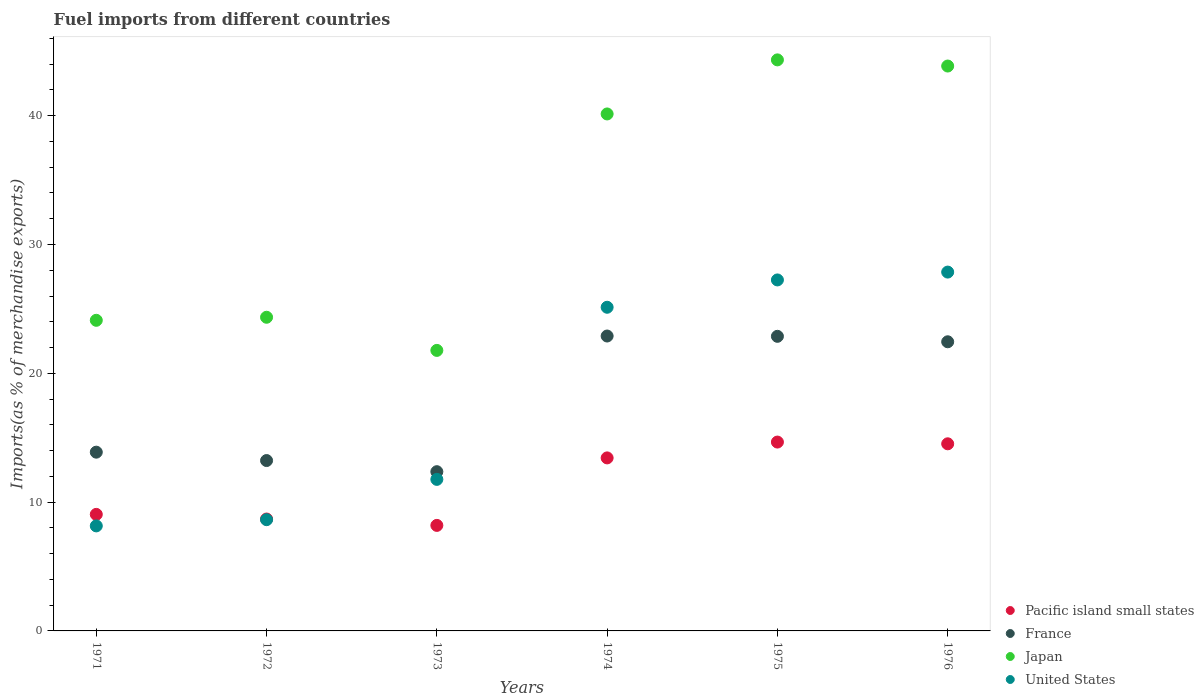How many different coloured dotlines are there?
Make the answer very short. 4. Is the number of dotlines equal to the number of legend labels?
Your answer should be very brief. Yes. What is the percentage of imports to different countries in Pacific island small states in 1972?
Your answer should be very brief. 8.69. Across all years, what is the maximum percentage of imports to different countries in Pacific island small states?
Make the answer very short. 14.66. Across all years, what is the minimum percentage of imports to different countries in United States?
Your answer should be compact. 8.15. In which year was the percentage of imports to different countries in Pacific island small states maximum?
Your answer should be very brief. 1975. In which year was the percentage of imports to different countries in Pacific island small states minimum?
Provide a short and direct response. 1973. What is the total percentage of imports to different countries in Japan in the graph?
Ensure brevity in your answer.  198.56. What is the difference between the percentage of imports to different countries in Japan in 1972 and that in 1974?
Offer a very short reply. -15.78. What is the difference between the percentage of imports to different countries in United States in 1971 and the percentage of imports to different countries in France in 1974?
Your answer should be compact. -14.74. What is the average percentage of imports to different countries in Pacific island small states per year?
Provide a short and direct response. 11.42. In the year 1971, what is the difference between the percentage of imports to different countries in Pacific island small states and percentage of imports to different countries in United States?
Give a very brief answer. 0.89. In how many years, is the percentage of imports to different countries in Japan greater than 2 %?
Give a very brief answer. 6. What is the ratio of the percentage of imports to different countries in Pacific island small states in 1971 to that in 1974?
Your answer should be very brief. 0.67. Is the percentage of imports to different countries in France in 1972 less than that in 1973?
Offer a very short reply. No. What is the difference between the highest and the second highest percentage of imports to different countries in France?
Offer a very short reply. 0.02. What is the difference between the highest and the lowest percentage of imports to different countries in Pacific island small states?
Keep it short and to the point. 6.47. In how many years, is the percentage of imports to different countries in United States greater than the average percentage of imports to different countries in United States taken over all years?
Provide a short and direct response. 3. Is the sum of the percentage of imports to different countries in United States in 1971 and 1974 greater than the maximum percentage of imports to different countries in France across all years?
Your answer should be compact. Yes. Is the percentage of imports to different countries in France strictly greater than the percentage of imports to different countries in Japan over the years?
Provide a succinct answer. No. Is the percentage of imports to different countries in France strictly less than the percentage of imports to different countries in United States over the years?
Your answer should be compact. No. How many dotlines are there?
Your response must be concise. 4. Are the values on the major ticks of Y-axis written in scientific E-notation?
Your answer should be compact. No. How many legend labels are there?
Offer a very short reply. 4. How are the legend labels stacked?
Offer a terse response. Vertical. What is the title of the graph?
Offer a terse response. Fuel imports from different countries. What is the label or title of the Y-axis?
Give a very brief answer. Imports(as % of merchandise exports). What is the Imports(as % of merchandise exports) in Pacific island small states in 1971?
Keep it short and to the point. 9.05. What is the Imports(as % of merchandise exports) in France in 1971?
Your response must be concise. 13.88. What is the Imports(as % of merchandise exports) in Japan in 1971?
Offer a very short reply. 24.11. What is the Imports(as % of merchandise exports) in United States in 1971?
Your answer should be very brief. 8.15. What is the Imports(as % of merchandise exports) of Pacific island small states in 1972?
Give a very brief answer. 8.69. What is the Imports(as % of merchandise exports) of France in 1972?
Provide a short and direct response. 13.23. What is the Imports(as % of merchandise exports) in Japan in 1972?
Offer a very short reply. 24.35. What is the Imports(as % of merchandise exports) in United States in 1972?
Your answer should be compact. 8.64. What is the Imports(as % of merchandise exports) in Pacific island small states in 1973?
Ensure brevity in your answer.  8.19. What is the Imports(as % of merchandise exports) in France in 1973?
Provide a short and direct response. 12.36. What is the Imports(as % of merchandise exports) in Japan in 1973?
Provide a succinct answer. 21.78. What is the Imports(as % of merchandise exports) in United States in 1973?
Your answer should be compact. 11.76. What is the Imports(as % of merchandise exports) of Pacific island small states in 1974?
Ensure brevity in your answer.  13.43. What is the Imports(as % of merchandise exports) in France in 1974?
Give a very brief answer. 22.89. What is the Imports(as % of merchandise exports) of Japan in 1974?
Your response must be concise. 40.13. What is the Imports(as % of merchandise exports) in United States in 1974?
Your answer should be compact. 25.13. What is the Imports(as % of merchandise exports) in Pacific island small states in 1975?
Provide a short and direct response. 14.66. What is the Imports(as % of merchandise exports) in France in 1975?
Give a very brief answer. 22.87. What is the Imports(as % of merchandise exports) in Japan in 1975?
Keep it short and to the point. 44.33. What is the Imports(as % of merchandise exports) of United States in 1975?
Provide a short and direct response. 27.25. What is the Imports(as % of merchandise exports) of Pacific island small states in 1976?
Offer a terse response. 14.53. What is the Imports(as % of merchandise exports) in France in 1976?
Your response must be concise. 22.45. What is the Imports(as % of merchandise exports) in Japan in 1976?
Keep it short and to the point. 43.85. What is the Imports(as % of merchandise exports) in United States in 1976?
Your response must be concise. 27.86. Across all years, what is the maximum Imports(as % of merchandise exports) of Pacific island small states?
Offer a very short reply. 14.66. Across all years, what is the maximum Imports(as % of merchandise exports) in France?
Offer a terse response. 22.89. Across all years, what is the maximum Imports(as % of merchandise exports) of Japan?
Make the answer very short. 44.33. Across all years, what is the maximum Imports(as % of merchandise exports) of United States?
Provide a short and direct response. 27.86. Across all years, what is the minimum Imports(as % of merchandise exports) of Pacific island small states?
Ensure brevity in your answer.  8.19. Across all years, what is the minimum Imports(as % of merchandise exports) of France?
Your response must be concise. 12.36. Across all years, what is the minimum Imports(as % of merchandise exports) of Japan?
Offer a terse response. 21.78. Across all years, what is the minimum Imports(as % of merchandise exports) in United States?
Your response must be concise. 8.15. What is the total Imports(as % of merchandise exports) of Pacific island small states in the graph?
Keep it short and to the point. 68.55. What is the total Imports(as % of merchandise exports) of France in the graph?
Offer a very short reply. 107.68. What is the total Imports(as % of merchandise exports) in Japan in the graph?
Ensure brevity in your answer.  198.56. What is the total Imports(as % of merchandise exports) in United States in the graph?
Make the answer very short. 108.79. What is the difference between the Imports(as % of merchandise exports) in Pacific island small states in 1971 and that in 1972?
Provide a short and direct response. 0.36. What is the difference between the Imports(as % of merchandise exports) in France in 1971 and that in 1972?
Your answer should be compact. 0.65. What is the difference between the Imports(as % of merchandise exports) in Japan in 1971 and that in 1972?
Offer a terse response. -0.24. What is the difference between the Imports(as % of merchandise exports) of United States in 1971 and that in 1972?
Make the answer very short. -0.48. What is the difference between the Imports(as % of merchandise exports) of Pacific island small states in 1971 and that in 1973?
Ensure brevity in your answer.  0.86. What is the difference between the Imports(as % of merchandise exports) of France in 1971 and that in 1973?
Your answer should be very brief. 1.51. What is the difference between the Imports(as % of merchandise exports) in Japan in 1971 and that in 1973?
Make the answer very short. 2.34. What is the difference between the Imports(as % of merchandise exports) of United States in 1971 and that in 1973?
Keep it short and to the point. -3.61. What is the difference between the Imports(as % of merchandise exports) of Pacific island small states in 1971 and that in 1974?
Offer a very short reply. -4.38. What is the difference between the Imports(as % of merchandise exports) of France in 1971 and that in 1974?
Your response must be concise. -9.02. What is the difference between the Imports(as % of merchandise exports) of Japan in 1971 and that in 1974?
Keep it short and to the point. -16.02. What is the difference between the Imports(as % of merchandise exports) in United States in 1971 and that in 1974?
Provide a succinct answer. -16.97. What is the difference between the Imports(as % of merchandise exports) of Pacific island small states in 1971 and that in 1975?
Provide a succinct answer. -5.61. What is the difference between the Imports(as % of merchandise exports) of France in 1971 and that in 1975?
Your answer should be compact. -8.99. What is the difference between the Imports(as % of merchandise exports) in Japan in 1971 and that in 1975?
Provide a succinct answer. -20.22. What is the difference between the Imports(as % of merchandise exports) of United States in 1971 and that in 1975?
Your response must be concise. -19.09. What is the difference between the Imports(as % of merchandise exports) in Pacific island small states in 1971 and that in 1976?
Keep it short and to the point. -5.48. What is the difference between the Imports(as % of merchandise exports) of France in 1971 and that in 1976?
Your answer should be compact. -8.57. What is the difference between the Imports(as % of merchandise exports) of Japan in 1971 and that in 1976?
Provide a succinct answer. -19.74. What is the difference between the Imports(as % of merchandise exports) in United States in 1971 and that in 1976?
Offer a terse response. -19.7. What is the difference between the Imports(as % of merchandise exports) of Pacific island small states in 1972 and that in 1973?
Keep it short and to the point. 0.49. What is the difference between the Imports(as % of merchandise exports) of France in 1972 and that in 1973?
Keep it short and to the point. 0.86. What is the difference between the Imports(as % of merchandise exports) in Japan in 1972 and that in 1973?
Provide a short and direct response. 2.57. What is the difference between the Imports(as % of merchandise exports) in United States in 1972 and that in 1973?
Offer a very short reply. -3.13. What is the difference between the Imports(as % of merchandise exports) of Pacific island small states in 1972 and that in 1974?
Offer a very short reply. -4.74. What is the difference between the Imports(as % of merchandise exports) of France in 1972 and that in 1974?
Give a very brief answer. -9.67. What is the difference between the Imports(as % of merchandise exports) in Japan in 1972 and that in 1974?
Keep it short and to the point. -15.78. What is the difference between the Imports(as % of merchandise exports) in United States in 1972 and that in 1974?
Offer a terse response. -16.49. What is the difference between the Imports(as % of merchandise exports) of Pacific island small states in 1972 and that in 1975?
Your answer should be compact. -5.97. What is the difference between the Imports(as % of merchandise exports) in France in 1972 and that in 1975?
Make the answer very short. -9.64. What is the difference between the Imports(as % of merchandise exports) in Japan in 1972 and that in 1975?
Give a very brief answer. -19.98. What is the difference between the Imports(as % of merchandise exports) in United States in 1972 and that in 1975?
Offer a very short reply. -18.61. What is the difference between the Imports(as % of merchandise exports) of Pacific island small states in 1972 and that in 1976?
Your answer should be compact. -5.84. What is the difference between the Imports(as % of merchandise exports) in France in 1972 and that in 1976?
Your answer should be compact. -9.22. What is the difference between the Imports(as % of merchandise exports) in Japan in 1972 and that in 1976?
Provide a short and direct response. -19.5. What is the difference between the Imports(as % of merchandise exports) in United States in 1972 and that in 1976?
Provide a short and direct response. -19.22. What is the difference between the Imports(as % of merchandise exports) in Pacific island small states in 1973 and that in 1974?
Offer a very short reply. -5.24. What is the difference between the Imports(as % of merchandise exports) in France in 1973 and that in 1974?
Give a very brief answer. -10.53. What is the difference between the Imports(as % of merchandise exports) of Japan in 1973 and that in 1974?
Your answer should be compact. -18.36. What is the difference between the Imports(as % of merchandise exports) of United States in 1973 and that in 1974?
Your response must be concise. -13.36. What is the difference between the Imports(as % of merchandise exports) of Pacific island small states in 1973 and that in 1975?
Provide a succinct answer. -6.47. What is the difference between the Imports(as % of merchandise exports) in France in 1973 and that in 1975?
Provide a succinct answer. -10.51. What is the difference between the Imports(as % of merchandise exports) of Japan in 1973 and that in 1975?
Offer a very short reply. -22.55. What is the difference between the Imports(as % of merchandise exports) in United States in 1973 and that in 1975?
Provide a succinct answer. -15.48. What is the difference between the Imports(as % of merchandise exports) in Pacific island small states in 1973 and that in 1976?
Keep it short and to the point. -6.33. What is the difference between the Imports(as % of merchandise exports) of France in 1973 and that in 1976?
Your response must be concise. -10.08. What is the difference between the Imports(as % of merchandise exports) in Japan in 1973 and that in 1976?
Offer a very short reply. -22.08. What is the difference between the Imports(as % of merchandise exports) in United States in 1973 and that in 1976?
Ensure brevity in your answer.  -16.09. What is the difference between the Imports(as % of merchandise exports) of Pacific island small states in 1974 and that in 1975?
Offer a terse response. -1.23. What is the difference between the Imports(as % of merchandise exports) of France in 1974 and that in 1975?
Your answer should be very brief. 0.02. What is the difference between the Imports(as % of merchandise exports) in Japan in 1974 and that in 1975?
Your response must be concise. -4.2. What is the difference between the Imports(as % of merchandise exports) of United States in 1974 and that in 1975?
Provide a short and direct response. -2.12. What is the difference between the Imports(as % of merchandise exports) in Pacific island small states in 1974 and that in 1976?
Your response must be concise. -1.09. What is the difference between the Imports(as % of merchandise exports) of France in 1974 and that in 1976?
Offer a terse response. 0.45. What is the difference between the Imports(as % of merchandise exports) in Japan in 1974 and that in 1976?
Your answer should be compact. -3.72. What is the difference between the Imports(as % of merchandise exports) in United States in 1974 and that in 1976?
Offer a very short reply. -2.73. What is the difference between the Imports(as % of merchandise exports) in Pacific island small states in 1975 and that in 1976?
Your response must be concise. 0.13. What is the difference between the Imports(as % of merchandise exports) of France in 1975 and that in 1976?
Your response must be concise. 0.42. What is the difference between the Imports(as % of merchandise exports) of Japan in 1975 and that in 1976?
Make the answer very short. 0.48. What is the difference between the Imports(as % of merchandise exports) of United States in 1975 and that in 1976?
Offer a very short reply. -0.61. What is the difference between the Imports(as % of merchandise exports) of Pacific island small states in 1971 and the Imports(as % of merchandise exports) of France in 1972?
Make the answer very short. -4.18. What is the difference between the Imports(as % of merchandise exports) in Pacific island small states in 1971 and the Imports(as % of merchandise exports) in Japan in 1972?
Your response must be concise. -15.3. What is the difference between the Imports(as % of merchandise exports) in Pacific island small states in 1971 and the Imports(as % of merchandise exports) in United States in 1972?
Give a very brief answer. 0.41. What is the difference between the Imports(as % of merchandise exports) in France in 1971 and the Imports(as % of merchandise exports) in Japan in 1972?
Your answer should be compact. -10.47. What is the difference between the Imports(as % of merchandise exports) of France in 1971 and the Imports(as % of merchandise exports) of United States in 1972?
Provide a succinct answer. 5.24. What is the difference between the Imports(as % of merchandise exports) of Japan in 1971 and the Imports(as % of merchandise exports) of United States in 1972?
Your response must be concise. 15.48. What is the difference between the Imports(as % of merchandise exports) of Pacific island small states in 1971 and the Imports(as % of merchandise exports) of France in 1973?
Offer a very short reply. -3.31. What is the difference between the Imports(as % of merchandise exports) of Pacific island small states in 1971 and the Imports(as % of merchandise exports) of Japan in 1973?
Your answer should be compact. -12.73. What is the difference between the Imports(as % of merchandise exports) of Pacific island small states in 1971 and the Imports(as % of merchandise exports) of United States in 1973?
Keep it short and to the point. -2.72. What is the difference between the Imports(as % of merchandise exports) of France in 1971 and the Imports(as % of merchandise exports) of Japan in 1973?
Make the answer very short. -7.9. What is the difference between the Imports(as % of merchandise exports) in France in 1971 and the Imports(as % of merchandise exports) in United States in 1973?
Your answer should be very brief. 2.11. What is the difference between the Imports(as % of merchandise exports) of Japan in 1971 and the Imports(as % of merchandise exports) of United States in 1973?
Provide a succinct answer. 12.35. What is the difference between the Imports(as % of merchandise exports) in Pacific island small states in 1971 and the Imports(as % of merchandise exports) in France in 1974?
Make the answer very short. -13.85. What is the difference between the Imports(as % of merchandise exports) in Pacific island small states in 1971 and the Imports(as % of merchandise exports) in Japan in 1974?
Ensure brevity in your answer.  -31.09. What is the difference between the Imports(as % of merchandise exports) in Pacific island small states in 1971 and the Imports(as % of merchandise exports) in United States in 1974?
Provide a short and direct response. -16.08. What is the difference between the Imports(as % of merchandise exports) in France in 1971 and the Imports(as % of merchandise exports) in Japan in 1974?
Ensure brevity in your answer.  -26.26. What is the difference between the Imports(as % of merchandise exports) in France in 1971 and the Imports(as % of merchandise exports) in United States in 1974?
Make the answer very short. -11.25. What is the difference between the Imports(as % of merchandise exports) of Japan in 1971 and the Imports(as % of merchandise exports) of United States in 1974?
Your response must be concise. -1.01. What is the difference between the Imports(as % of merchandise exports) of Pacific island small states in 1971 and the Imports(as % of merchandise exports) of France in 1975?
Keep it short and to the point. -13.82. What is the difference between the Imports(as % of merchandise exports) of Pacific island small states in 1971 and the Imports(as % of merchandise exports) of Japan in 1975?
Offer a very short reply. -35.28. What is the difference between the Imports(as % of merchandise exports) of Pacific island small states in 1971 and the Imports(as % of merchandise exports) of United States in 1975?
Your answer should be compact. -18.2. What is the difference between the Imports(as % of merchandise exports) in France in 1971 and the Imports(as % of merchandise exports) in Japan in 1975?
Keep it short and to the point. -30.45. What is the difference between the Imports(as % of merchandise exports) of France in 1971 and the Imports(as % of merchandise exports) of United States in 1975?
Provide a succinct answer. -13.37. What is the difference between the Imports(as % of merchandise exports) of Japan in 1971 and the Imports(as % of merchandise exports) of United States in 1975?
Offer a very short reply. -3.13. What is the difference between the Imports(as % of merchandise exports) in Pacific island small states in 1971 and the Imports(as % of merchandise exports) in France in 1976?
Keep it short and to the point. -13.4. What is the difference between the Imports(as % of merchandise exports) in Pacific island small states in 1971 and the Imports(as % of merchandise exports) in Japan in 1976?
Provide a short and direct response. -34.81. What is the difference between the Imports(as % of merchandise exports) in Pacific island small states in 1971 and the Imports(as % of merchandise exports) in United States in 1976?
Your answer should be compact. -18.81. What is the difference between the Imports(as % of merchandise exports) of France in 1971 and the Imports(as % of merchandise exports) of Japan in 1976?
Provide a succinct answer. -29.98. What is the difference between the Imports(as % of merchandise exports) in France in 1971 and the Imports(as % of merchandise exports) in United States in 1976?
Your answer should be very brief. -13.98. What is the difference between the Imports(as % of merchandise exports) in Japan in 1971 and the Imports(as % of merchandise exports) in United States in 1976?
Your answer should be compact. -3.74. What is the difference between the Imports(as % of merchandise exports) of Pacific island small states in 1972 and the Imports(as % of merchandise exports) of France in 1973?
Offer a very short reply. -3.67. What is the difference between the Imports(as % of merchandise exports) in Pacific island small states in 1972 and the Imports(as % of merchandise exports) in Japan in 1973?
Offer a very short reply. -13.09. What is the difference between the Imports(as % of merchandise exports) of Pacific island small states in 1972 and the Imports(as % of merchandise exports) of United States in 1973?
Your answer should be very brief. -3.08. What is the difference between the Imports(as % of merchandise exports) of France in 1972 and the Imports(as % of merchandise exports) of Japan in 1973?
Make the answer very short. -8.55. What is the difference between the Imports(as % of merchandise exports) in France in 1972 and the Imports(as % of merchandise exports) in United States in 1973?
Your answer should be compact. 1.46. What is the difference between the Imports(as % of merchandise exports) of Japan in 1972 and the Imports(as % of merchandise exports) of United States in 1973?
Make the answer very short. 12.59. What is the difference between the Imports(as % of merchandise exports) of Pacific island small states in 1972 and the Imports(as % of merchandise exports) of France in 1974?
Your response must be concise. -14.21. What is the difference between the Imports(as % of merchandise exports) in Pacific island small states in 1972 and the Imports(as % of merchandise exports) in Japan in 1974?
Offer a very short reply. -31.45. What is the difference between the Imports(as % of merchandise exports) in Pacific island small states in 1972 and the Imports(as % of merchandise exports) in United States in 1974?
Your answer should be compact. -16.44. What is the difference between the Imports(as % of merchandise exports) in France in 1972 and the Imports(as % of merchandise exports) in Japan in 1974?
Provide a succinct answer. -26.91. What is the difference between the Imports(as % of merchandise exports) of France in 1972 and the Imports(as % of merchandise exports) of United States in 1974?
Keep it short and to the point. -11.9. What is the difference between the Imports(as % of merchandise exports) of Japan in 1972 and the Imports(as % of merchandise exports) of United States in 1974?
Offer a very short reply. -0.78. What is the difference between the Imports(as % of merchandise exports) of Pacific island small states in 1972 and the Imports(as % of merchandise exports) of France in 1975?
Provide a succinct answer. -14.18. What is the difference between the Imports(as % of merchandise exports) in Pacific island small states in 1972 and the Imports(as % of merchandise exports) in Japan in 1975?
Provide a succinct answer. -35.64. What is the difference between the Imports(as % of merchandise exports) in Pacific island small states in 1972 and the Imports(as % of merchandise exports) in United States in 1975?
Give a very brief answer. -18.56. What is the difference between the Imports(as % of merchandise exports) of France in 1972 and the Imports(as % of merchandise exports) of Japan in 1975?
Your answer should be compact. -31.1. What is the difference between the Imports(as % of merchandise exports) of France in 1972 and the Imports(as % of merchandise exports) of United States in 1975?
Make the answer very short. -14.02. What is the difference between the Imports(as % of merchandise exports) in Japan in 1972 and the Imports(as % of merchandise exports) in United States in 1975?
Give a very brief answer. -2.9. What is the difference between the Imports(as % of merchandise exports) in Pacific island small states in 1972 and the Imports(as % of merchandise exports) in France in 1976?
Keep it short and to the point. -13.76. What is the difference between the Imports(as % of merchandise exports) in Pacific island small states in 1972 and the Imports(as % of merchandise exports) in Japan in 1976?
Give a very brief answer. -35.17. What is the difference between the Imports(as % of merchandise exports) in Pacific island small states in 1972 and the Imports(as % of merchandise exports) in United States in 1976?
Offer a very short reply. -19.17. What is the difference between the Imports(as % of merchandise exports) in France in 1972 and the Imports(as % of merchandise exports) in Japan in 1976?
Provide a short and direct response. -30.63. What is the difference between the Imports(as % of merchandise exports) in France in 1972 and the Imports(as % of merchandise exports) in United States in 1976?
Keep it short and to the point. -14.63. What is the difference between the Imports(as % of merchandise exports) in Japan in 1972 and the Imports(as % of merchandise exports) in United States in 1976?
Offer a terse response. -3.51. What is the difference between the Imports(as % of merchandise exports) in Pacific island small states in 1973 and the Imports(as % of merchandise exports) in France in 1974?
Provide a succinct answer. -14.7. What is the difference between the Imports(as % of merchandise exports) of Pacific island small states in 1973 and the Imports(as % of merchandise exports) of Japan in 1974?
Your answer should be very brief. -31.94. What is the difference between the Imports(as % of merchandise exports) of Pacific island small states in 1973 and the Imports(as % of merchandise exports) of United States in 1974?
Keep it short and to the point. -16.93. What is the difference between the Imports(as % of merchandise exports) of France in 1973 and the Imports(as % of merchandise exports) of Japan in 1974?
Ensure brevity in your answer.  -27.77. What is the difference between the Imports(as % of merchandise exports) in France in 1973 and the Imports(as % of merchandise exports) in United States in 1974?
Offer a very short reply. -12.76. What is the difference between the Imports(as % of merchandise exports) in Japan in 1973 and the Imports(as % of merchandise exports) in United States in 1974?
Provide a succinct answer. -3.35. What is the difference between the Imports(as % of merchandise exports) of Pacific island small states in 1973 and the Imports(as % of merchandise exports) of France in 1975?
Make the answer very short. -14.68. What is the difference between the Imports(as % of merchandise exports) of Pacific island small states in 1973 and the Imports(as % of merchandise exports) of Japan in 1975?
Your response must be concise. -36.14. What is the difference between the Imports(as % of merchandise exports) of Pacific island small states in 1973 and the Imports(as % of merchandise exports) of United States in 1975?
Provide a short and direct response. -19.06. What is the difference between the Imports(as % of merchandise exports) of France in 1973 and the Imports(as % of merchandise exports) of Japan in 1975?
Your answer should be very brief. -31.97. What is the difference between the Imports(as % of merchandise exports) in France in 1973 and the Imports(as % of merchandise exports) in United States in 1975?
Offer a terse response. -14.89. What is the difference between the Imports(as % of merchandise exports) of Japan in 1973 and the Imports(as % of merchandise exports) of United States in 1975?
Keep it short and to the point. -5.47. What is the difference between the Imports(as % of merchandise exports) of Pacific island small states in 1973 and the Imports(as % of merchandise exports) of France in 1976?
Your answer should be compact. -14.25. What is the difference between the Imports(as % of merchandise exports) of Pacific island small states in 1973 and the Imports(as % of merchandise exports) of Japan in 1976?
Provide a succinct answer. -35.66. What is the difference between the Imports(as % of merchandise exports) of Pacific island small states in 1973 and the Imports(as % of merchandise exports) of United States in 1976?
Make the answer very short. -19.66. What is the difference between the Imports(as % of merchandise exports) of France in 1973 and the Imports(as % of merchandise exports) of Japan in 1976?
Ensure brevity in your answer.  -31.49. What is the difference between the Imports(as % of merchandise exports) of France in 1973 and the Imports(as % of merchandise exports) of United States in 1976?
Your answer should be very brief. -15.5. What is the difference between the Imports(as % of merchandise exports) in Japan in 1973 and the Imports(as % of merchandise exports) in United States in 1976?
Offer a terse response. -6.08. What is the difference between the Imports(as % of merchandise exports) of Pacific island small states in 1974 and the Imports(as % of merchandise exports) of France in 1975?
Your answer should be compact. -9.44. What is the difference between the Imports(as % of merchandise exports) in Pacific island small states in 1974 and the Imports(as % of merchandise exports) in Japan in 1975?
Offer a very short reply. -30.9. What is the difference between the Imports(as % of merchandise exports) in Pacific island small states in 1974 and the Imports(as % of merchandise exports) in United States in 1975?
Ensure brevity in your answer.  -13.82. What is the difference between the Imports(as % of merchandise exports) of France in 1974 and the Imports(as % of merchandise exports) of Japan in 1975?
Your answer should be compact. -21.44. What is the difference between the Imports(as % of merchandise exports) of France in 1974 and the Imports(as % of merchandise exports) of United States in 1975?
Ensure brevity in your answer.  -4.35. What is the difference between the Imports(as % of merchandise exports) of Japan in 1974 and the Imports(as % of merchandise exports) of United States in 1975?
Your answer should be very brief. 12.89. What is the difference between the Imports(as % of merchandise exports) of Pacific island small states in 1974 and the Imports(as % of merchandise exports) of France in 1976?
Give a very brief answer. -9.01. What is the difference between the Imports(as % of merchandise exports) in Pacific island small states in 1974 and the Imports(as % of merchandise exports) in Japan in 1976?
Provide a short and direct response. -30.42. What is the difference between the Imports(as % of merchandise exports) in Pacific island small states in 1974 and the Imports(as % of merchandise exports) in United States in 1976?
Offer a terse response. -14.43. What is the difference between the Imports(as % of merchandise exports) in France in 1974 and the Imports(as % of merchandise exports) in Japan in 1976?
Your answer should be very brief. -20.96. What is the difference between the Imports(as % of merchandise exports) in France in 1974 and the Imports(as % of merchandise exports) in United States in 1976?
Your answer should be compact. -4.96. What is the difference between the Imports(as % of merchandise exports) of Japan in 1974 and the Imports(as % of merchandise exports) of United States in 1976?
Your answer should be compact. 12.28. What is the difference between the Imports(as % of merchandise exports) in Pacific island small states in 1975 and the Imports(as % of merchandise exports) in France in 1976?
Offer a very short reply. -7.79. What is the difference between the Imports(as % of merchandise exports) of Pacific island small states in 1975 and the Imports(as % of merchandise exports) of Japan in 1976?
Keep it short and to the point. -29.19. What is the difference between the Imports(as % of merchandise exports) in Pacific island small states in 1975 and the Imports(as % of merchandise exports) in United States in 1976?
Give a very brief answer. -13.2. What is the difference between the Imports(as % of merchandise exports) of France in 1975 and the Imports(as % of merchandise exports) of Japan in 1976?
Offer a terse response. -20.98. What is the difference between the Imports(as % of merchandise exports) in France in 1975 and the Imports(as % of merchandise exports) in United States in 1976?
Provide a succinct answer. -4.99. What is the difference between the Imports(as % of merchandise exports) of Japan in 1975 and the Imports(as % of merchandise exports) of United States in 1976?
Keep it short and to the point. 16.47. What is the average Imports(as % of merchandise exports) of Pacific island small states per year?
Keep it short and to the point. 11.42. What is the average Imports(as % of merchandise exports) in France per year?
Your answer should be very brief. 17.95. What is the average Imports(as % of merchandise exports) of Japan per year?
Keep it short and to the point. 33.09. What is the average Imports(as % of merchandise exports) of United States per year?
Your answer should be compact. 18.13. In the year 1971, what is the difference between the Imports(as % of merchandise exports) in Pacific island small states and Imports(as % of merchandise exports) in France?
Provide a short and direct response. -4.83. In the year 1971, what is the difference between the Imports(as % of merchandise exports) in Pacific island small states and Imports(as % of merchandise exports) in Japan?
Offer a terse response. -15.07. In the year 1971, what is the difference between the Imports(as % of merchandise exports) of Pacific island small states and Imports(as % of merchandise exports) of United States?
Offer a terse response. 0.89. In the year 1971, what is the difference between the Imports(as % of merchandise exports) in France and Imports(as % of merchandise exports) in Japan?
Your answer should be compact. -10.24. In the year 1971, what is the difference between the Imports(as % of merchandise exports) in France and Imports(as % of merchandise exports) in United States?
Give a very brief answer. 5.72. In the year 1971, what is the difference between the Imports(as % of merchandise exports) of Japan and Imports(as % of merchandise exports) of United States?
Your answer should be compact. 15.96. In the year 1972, what is the difference between the Imports(as % of merchandise exports) in Pacific island small states and Imports(as % of merchandise exports) in France?
Offer a terse response. -4.54. In the year 1972, what is the difference between the Imports(as % of merchandise exports) in Pacific island small states and Imports(as % of merchandise exports) in Japan?
Provide a succinct answer. -15.66. In the year 1972, what is the difference between the Imports(as % of merchandise exports) in France and Imports(as % of merchandise exports) in Japan?
Your answer should be very brief. -11.12. In the year 1972, what is the difference between the Imports(as % of merchandise exports) in France and Imports(as % of merchandise exports) in United States?
Ensure brevity in your answer.  4.59. In the year 1972, what is the difference between the Imports(as % of merchandise exports) in Japan and Imports(as % of merchandise exports) in United States?
Keep it short and to the point. 15.71. In the year 1973, what is the difference between the Imports(as % of merchandise exports) in Pacific island small states and Imports(as % of merchandise exports) in France?
Provide a succinct answer. -4.17. In the year 1973, what is the difference between the Imports(as % of merchandise exports) of Pacific island small states and Imports(as % of merchandise exports) of Japan?
Provide a short and direct response. -13.59. In the year 1973, what is the difference between the Imports(as % of merchandise exports) in Pacific island small states and Imports(as % of merchandise exports) in United States?
Make the answer very short. -3.57. In the year 1973, what is the difference between the Imports(as % of merchandise exports) of France and Imports(as % of merchandise exports) of Japan?
Your answer should be very brief. -9.42. In the year 1973, what is the difference between the Imports(as % of merchandise exports) of France and Imports(as % of merchandise exports) of United States?
Offer a terse response. 0.6. In the year 1973, what is the difference between the Imports(as % of merchandise exports) in Japan and Imports(as % of merchandise exports) in United States?
Ensure brevity in your answer.  10.01. In the year 1974, what is the difference between the Imports(as % of merchandise exports) in Pacific island small states and Imports(as % of merchandise exports) in France?
Your answer should be very brief. -9.46. In the year 1974, what is the difference between the Imports(as % of merchandise exports) of Pacific island small states and Imports(as % of merchandise exports) of Japan?
Keep it short and to the point. -26.7. In the year 1974, what is the difference between the Imports(as % of merchandise exports) of Pacific island small states and Imports(as % of merchandise exports) of United States?
Give a very brief answer. -11.69. In the year 1974, what is the difference between the Imports(as % of merchandise exports) of France and Imports(as % of merchandise exports) of Japan?
Keep it short and to the point. -17.24. In the year 1974, what is the difference between the Imports(as % of merchandise exports) in France and Imports(as % of merchandise exports) in United States?
Make the answer very short. -2.23. In the year 1974, what is the difference between the Imports(as % of merchandise exports) in Japan and Imports(as % of merchandise exports) in United States?
Your answer should be compact. 15.01. In the year 1975, what is the difference between the Imports(as % of merchandise exports) of Pacific island small states and Imports(as % of merchandise exports) of France?
Your answer should be compact. -8.21. In the year 1975, what is the difference between the Imports(as % of merchandise exports) in Pacific island small states and Imports(as % of merchandise exports) in Japan?
Your answer should be very brief. -29.67. In the year 1975, what is the difference between the Imports(as % of merchandise exports) of Pacific island small states and Imports(as % of merchandise exports) of United States?
Give a very brief answer. -12.59. In the year 1975, what is the difference between the Imports(as % of merchandise exports) in France and Imports(as % of merchandise exports) in Japan?
Your answer should be compact. -21.46. In the year 1975, what is the difference between the Imports(as % of merchandise exports) in France and Imports(as % of merchandise exports) in United States?
Offer a very short reply. -4.38. In the year 1975, what is the difference between the Imports(as % of merchandise exports) in Japan and Imports(as % of merchandise exports) in United States?
Offer a very short reply. 17.08. In the year 1976, what is the difference between the Imports(as % of merchandise exports) in Pacific island small states and Imports(as % of merchandise exports) in France?
Provide a succinct answer. -7.92. In the year 1976, what is the difference between the Imports(as % of merchandise exports) in Pacific island small states and Imports(as % of merchandise exports) in Japan?
Offer a very short reply. -29.33. In the year 1976, what is the difference between the Imports(as % of merchandise exports) of Pacific island small states and Imports(as % of merchandise exports) of United States?
Your answer should be very brief. -13.33. In the year 1976, what is the difference between the Imports(as % of merchandise exports) in France and Imports(as % of merchandise exports) in Japan?
Ensure brevity in your answer.  -21.41. In the year 1976, what is the difference between the Imports(as % of merchandise exports) of France and Imports(as % of merchandise exports) of United States?
Make the answer very short. -5.41. In the year 1976, what is the difference between the Imports(as % of merchandise exports) in Japan and Imports(as % of merchandise exports) in United States?
Give a very brief answer. 16. What is the ratio of the Imports(as % of merchandise exports) of Pacific island small states in 1971 to that in 1972?
Provide a short and direct response. 1.04. What is the ratio of the Imports(as % of merchandise exports) of France in 1971 to that in 1972?
Your response must be concise. 1.05. What is the ratio of the Imports(as % of merchandise exports) in Japan in 1971 to that in 1972?
Your response must be concise. 0.99. What is the ratio of the Imports(as % of merchandise exports) of United States in 1971 to that in 1972?
Offer a very short reply. 0.94. What is the ratio of the Imports(as % of merchandise exports) in Pacific island small states in 1971 to that in 1973?
Offer a terse response. 1.1. What is the ratio of the Imports(as % of merchandise exports) in France in 1971 to that in 1973?
Offer a terse response. 1.12. What is the ratio of the Imports(as % of merchandise exports) of Japan in 1971 to that in 1973?
Keep it short and to the point. 1.11. What is the ratio of the Imports(as % of merchandise exports) in United States in 1971 to that in 1973?
Make the answer very short. 0.69. What is the ratio of the Imports(as % of merchandise exports) in Pacific island small states in 1971 to that in 1974?
Your response must be concise. 0.67. What is the ratio of the Imports(as % of merchandise exports) in France in 1971 to that in 1974?
Keep it short and to the point. 0.61. What is the ratio of the Imports(as % of merchandise exports) in Japan in 1971 to that in 1974?
Offer a terse response. 0.6. What is the ratio of the Imports(as % of merchandise exports) in United States in 1971 to that in 1974?
Your answer should be very brief. 0.32. What is the ratio of the Imports(as % of merchandise exports) in Pacific island small states in 1971 to that in 1975?
Provide a short and direct response. 0.62. What is the ratio of the Imports(as % of merchandise exports) of France in 1971 to that in 1975?
Give a very brief answer. 0.61. What is the ratio of the Imports(as % of merchandise exports) of Japan in 1971 to that in 1975?
Make the answer very short. 0.54. What is the ratio of the Imports(as % of merchandise exports) in United States in 1971 to that in 1975?
Offer a terse response. 0.3. What is the ratio of the Imports(as % of merchandise exports) in Pacific island small states in 1971 to that in 1976?
Keep it short and to the point. 0.62. What is the ratio of the Imports(as % of merchandise exports) of France in 1971 to that in 1976?
Provide a short and direct response. 0.62. What is the ratio of the Imports(as % of merchandise exports) of Japan in 1971 to that in 1976?
Offer a very short reply. 0.55. What is the ratio of the Imports(as % of merchandise exports) of United States in 1971 to that in 1976?
Offer a terse response. 0.29. What is the ratio of the Imports(as % of merchandise exports) in Pacific island small states in 1972 to that in 1973?
Make the answer very short. 1.06. What is the ratio of the Imports(as % of merchandise exports) in France in 1972 to that in 1973?
Ensure brevity in your answer.  1.07. What is the ratio of the Imports(as % of merchandise exports) of Japan in 1972 to that in 1973?
Provide a succinct answer. 1.12. What is the ratio of the Imports(as % of merchandise exports) of United States in 1972 to that in 1973?
Provide a succinct answer. 0.73. What is the ratio of the Imports(as % of merchandise exports) of Pacific island small states in 1972 to that in 1974?
Offer a very short reply. 0.65. What is the ratio of the Imports(as % of merchandise exports) in France in 1972 to that in 1974?
Your answer should be very brief. 0.58. What is the ratio of the Imports(as % of merchandise exports) in Japan in 1972 to that in 1974?
Make the answer very short. 0.61. What is the ratio of the Imports(as % of merchandise exports) in United States in 1972 to that in 1974?
Offer a very short reply. 0.34. What is the ratio of the Imports(as % of merchandise exports) of Pacific island small states in 1972 to that in 1975?
Your response must be concise. 0.59. What is the ratio of the Imports(as % of merchandise exports) of France in 1972 to that in 1975?
Your answer should be very brief. 0.58. What is the ratio of the Imports(as % of merchandise exports) in Japan in 1972 to that in 1975?
Your answer should be very brief. 0.55. What is the ratio of the Imports(as % of merchandise exports) in United States in 1972 to that in 1975?
Your answer should be compact. 0.32. What is the ratio of the Imports(as % of merchandise exports) of Pacific island small states in 1972 to that in 1976?
Offer a very short reply. 0.6. What is the ratio of the Imports(as % of merchandise exports) in France in 1972 to that in 1976?
Make the answer very short. 0.59. What is the ratio of the Imports(as % of merchandise exports) in Japan in 1972 to that in 1976?
Provide a short and direct response. 0.56. What is the ratio of the Imports(as % of merchandise exports) in United States in 1972 to that in 1976?
Make the answer very short. 0.31. What is the ratio of the Imports(as % of merchandise exports) in Pacific island small states in 1973 to that in 1974?
Keep it short and to the point. 0.61. What is the ratio of the Imports(as % of merchandise exports) of France in 1973 to that in 1974?
Your answer should be very brief. 0.54. What is the ratio of the Imports(as % of merchandise exports) in Japan in 1973 to that in 1974?
Your answer should be very brief. 0.54. What is the ratio of the Imports(as % of merchandise exports) in United States in 1973 to that in 1974?
Your answer should be very brief. 0.47. What is the ratio of the Imports(as % of merchandise exports) of Pacific island small states in 1973 to that in 1975?
Your answer should be very brief. 0.56. What is the ratio of the Imports(as % of merchandise exports) in France in 1973 to that in 1975?
Your response must be concise. 0.54. What is the ratio of the Imports(as % of merchandise exports) in Japan in 1973 to that in 1975?
Give a very brief answer. 0.49. What is the ratio of the Imports(as % of merchandise exports) of United States in 1973 to that in 1975?
Offer a very short reply. 0.43. What is the ratio of the Imports(as % of merchandise exports) in Pacific island small states in 1973 to that in 1976?
Your response must be concise. 0.56. What is the ratio of the Imports(as % of merchandise exports) of France in 1973 to that in 1976?
Keep it short and to the point. 0.55. What is the ratio of the Imports(as % of merchandise exports) in Japan in 1973 to that in 1976?
Give a very brief answer. 0.5. What is the ratio of the Imports(as % of merchandise exports) of United States in 1973 to that in 1976?
Offer a very short reply. 0.42. What is the ratio of the Imports(as % of merchandise exports) of Pacific island small states in 1974 to that in 1975?
Offer a very short reply. 0.92. What is the ratio of the Imports(as % of merchandise exports) in France in 1974 to that in 1975?
Give a very brief answer. 1. What is the ratio of the Imports(as % of merchandise exports) in Japan in 1974 to that in 1975?
Offer a terse response. 0.91. What is the ratio of the Imports(as % of merchandise exports) in United States in 1974 to that in 1975?
Provide a succinct answer. 0.92. What is the ratio of the Imports(as % of merchandise exports) in Pacific island small states in 1974 to that in 1976?
Provide a short and direct response. 0.92. What is the ratio of the Imports(as % of merchandise exports) of France in 1974 to that in 1976?
Provide a short and direct response. 1.02. What is the ratio of the Imports(as % of merchandise exports) in Japan in 1974 to that in 1976?
Ensure brevity in your answer.  0.92. What is the ratio of the Imports(as % of merchandise exports) of United States in 1974 to that in 1976?
Ensure brevity in your answer.  0.9. What is the ratio of the Imports(as % of merchandise exports) of Pacific island small states in 1975 to that in 1976?
Offer a very short reply. 1.01. What is the ratio of the Imports(as % of merchandise exports) of France in 1975 to that in 1976?
Your answer should be compact. 1.02. What is the ratio of the Imports(as % of merchandise exports) in Japan in 1975 to that in 1976?
Your response must be concise. 1.01. What is the ratio of the Imports(as % of merchandise exports) of United States in 1975 to that in 1976?
Give a very brief answer. 0.98. What is the difference between the highest and the second highest Imports(as % of merchandise exports) of Pacific island small states?
Provide a short and direct response. 0.13. What is the difference between the highest and the second highest Imports(as % of merchandise exports) in France?
Provide a succinct answer. 0.02. What is the difference between the highest and the second highest Imports(as % of merchandise exports) in Japan?
Make the answer very short. 0.48. What is the difference between the highest and the second highest Imports(as % of merchandise exports) in United States?
Give a very brief answer. 0.61. What is the difference between the highest and the lowest Imports(as % of merchandise exports) in Pacific island small states?
Provide a succinct answer. 6.47. What is the difference between the highest and the lowest Imports(as % of merchandise exports) of France?
Offer a terse response. 10.53. What is the difference between the highest and the lowest Imports(as % of merchandise exports) of Japan?
Offer a terse response. 22.55. What is the difference between the highest and the lowest Imports(as % of merchandise exports) in United States?
Give a very brief answer. 19.7. 